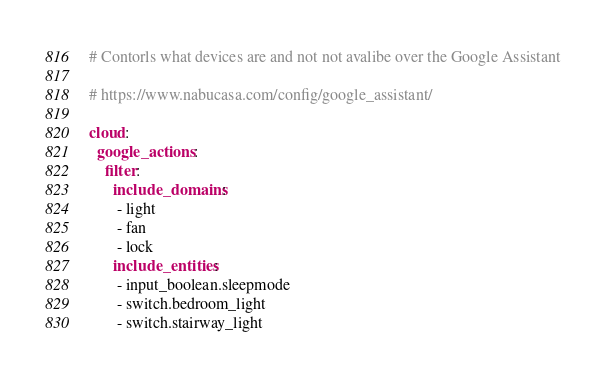Convert code to text. <code><loc_0><loc_0><loc_500><loc_500><_YAML_># Contorls what devices are and not not avalibe over the Google Assistant

# https://www.nabucasa.com/config/google_assistant/
  
cloud:
  google_actions:
    filter:
      include_domains:
       - light
       - fan
       - lock
      include_entities:
       - input_boolean.sleepmode
       - switch.bedroom_light
       - switch.stairway_light</code> 